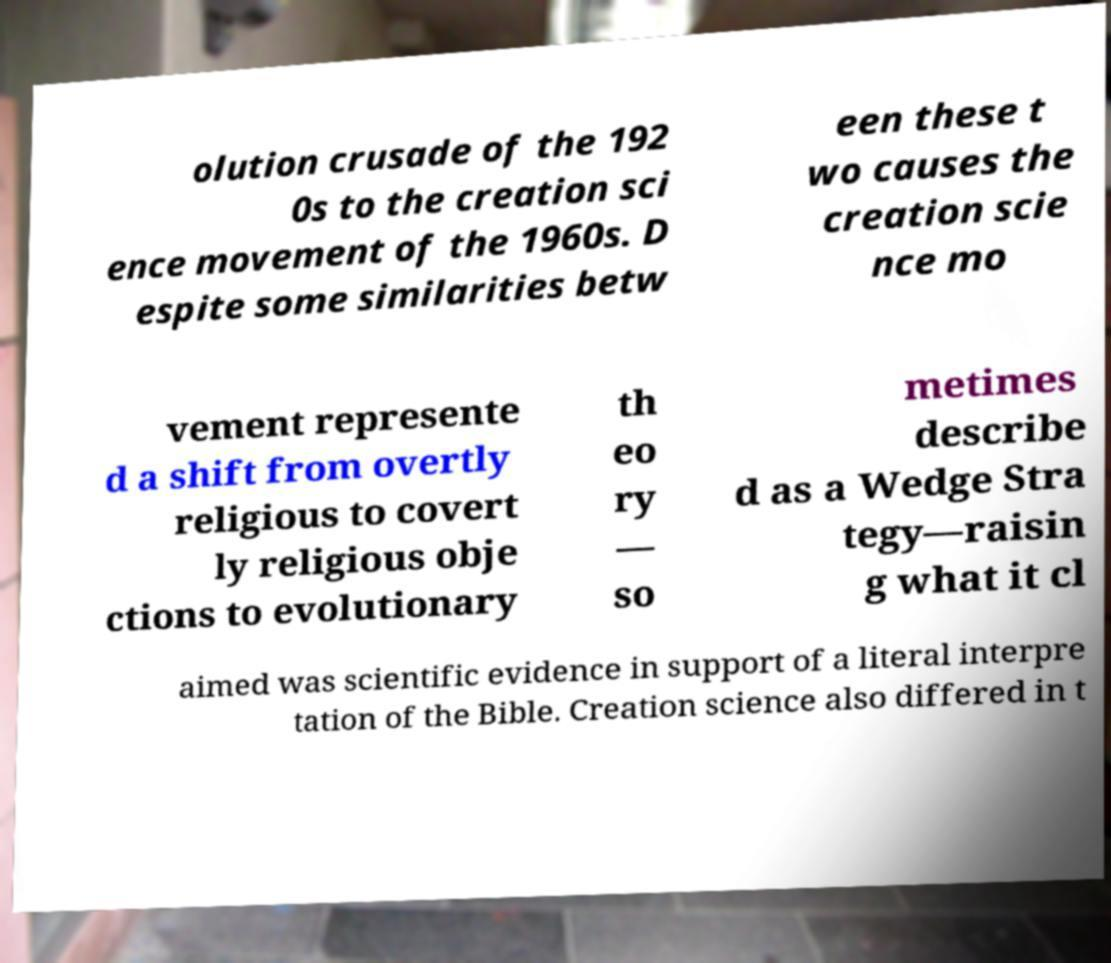Could you assist in decoding the text presented in this image and type it out clearly? olution crusade of the 192 0s to the creation sci ence movement of the 1960s. D espite some similarities betw een these t wo causes the creation scie nce mo vement represente d a shift from overtly religious to covert ly religious obje ctions to evolutionary th eo ry — so metimes describe d as a Wedge Stra tegy—raisin g what it cl aimed was scientific evidence in support of a literal interpre tation of the Bible. Creation science also differed in t 